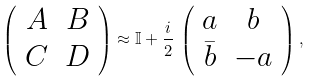Convert formula to latex. <formula><loc_0><loc_0><loc_500><loc_500>\left ( \begin{array} { c c } A & B \\ C & D \end{array} \right ) \approx \mathbb { I } + \frac { i } { 2 } \, \left ( \begin{array} { c c } a & b \\ \bar { b } & - a \end{array} \right ) ,</formula> 